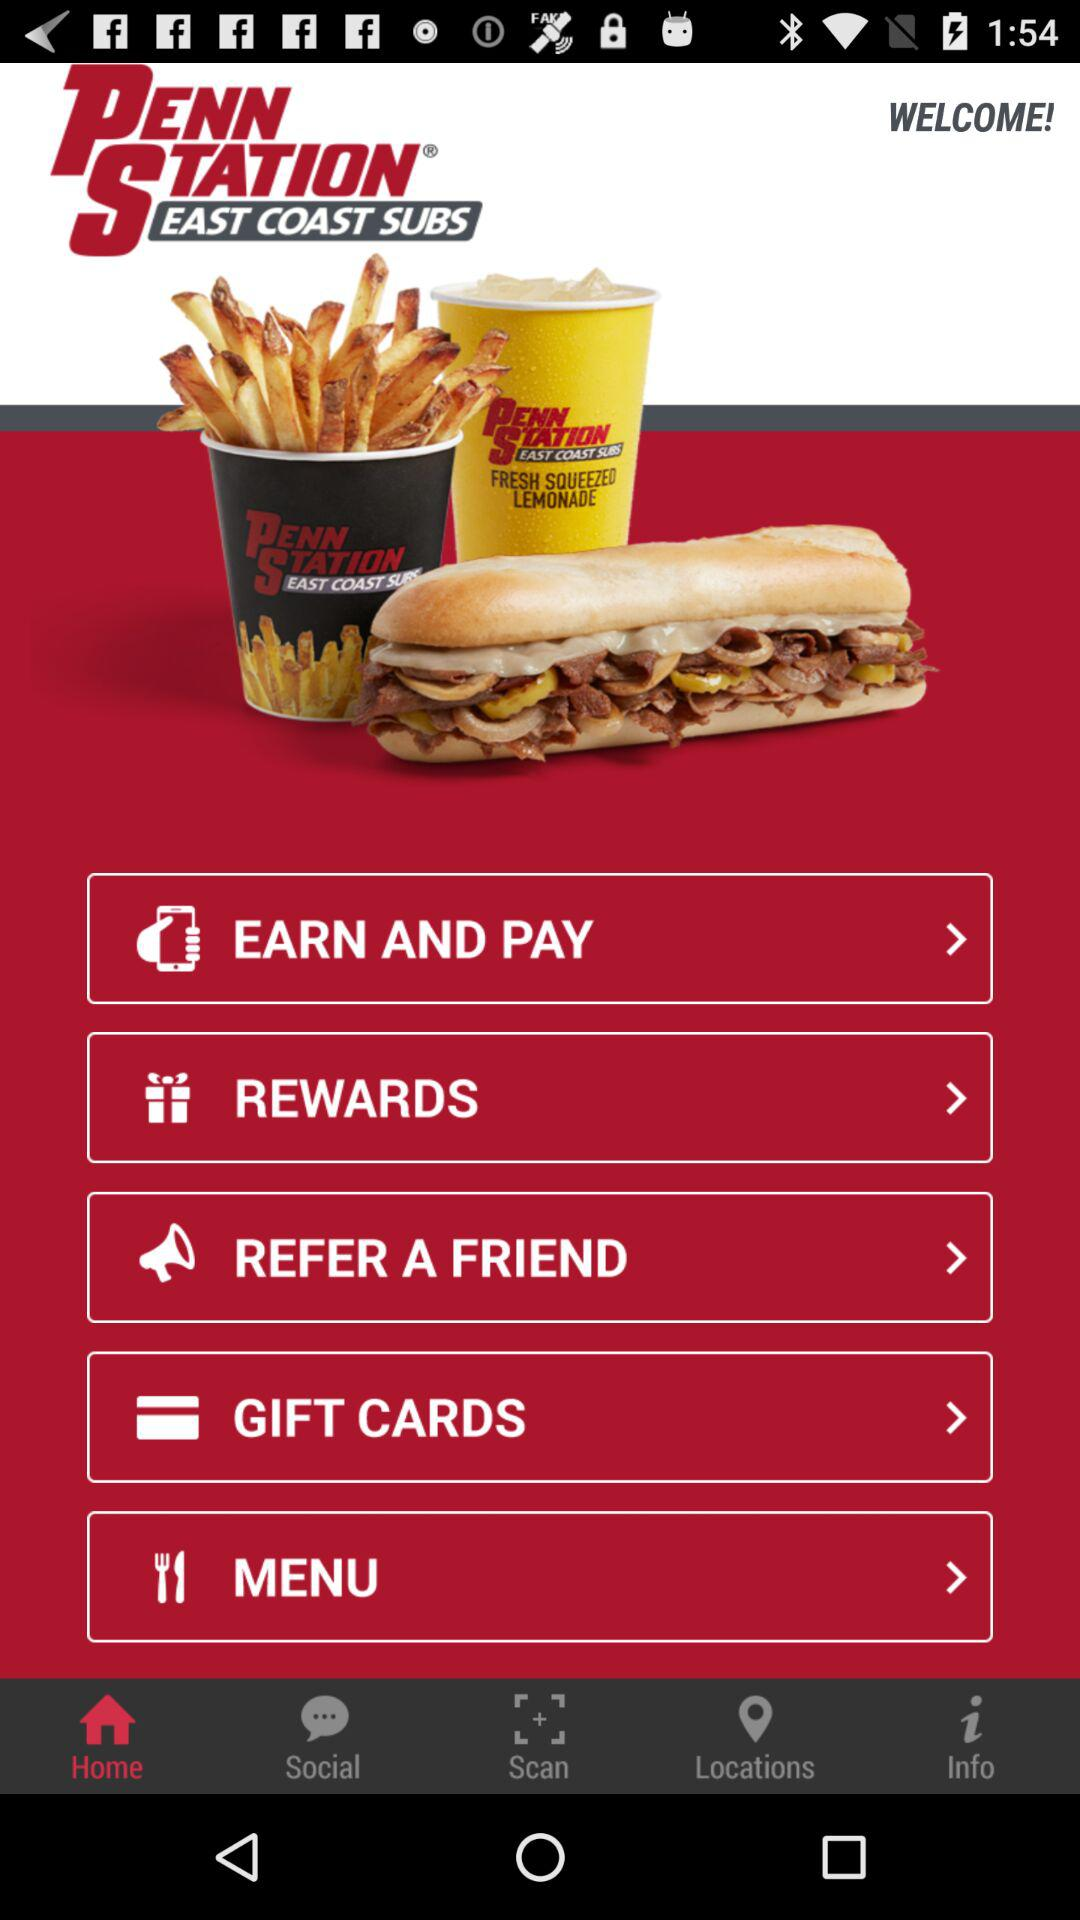What is the application name? The application name is "PENN STATION EAST COAST SUBS". 